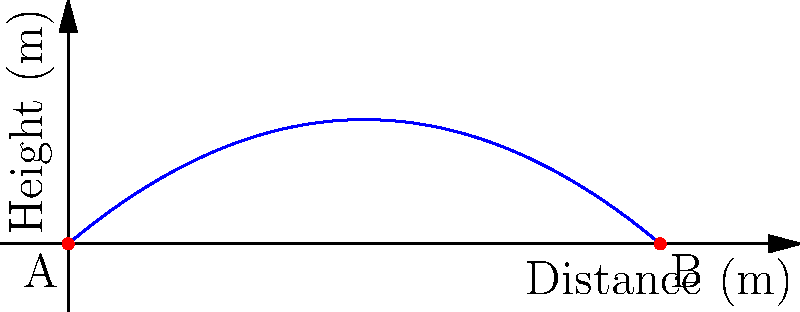As a female footballer promoting women's sports, you're demonstrating a powerful kick to inspire young girls. You kick a football with an initial velocity of 25 m/s at an angle of 40° above the horizontal. Assuming no air resistance, what is the maximum distance the ball will travel before hitting the ground? (Use $g = 9.8$ m/s², and round your answer to the nearest meter.) To solve this problem, we'll use the equations of projectile motion:

1) First, let's break down the initial velocity into its x and y components:
   $v_{0x} = v_0 \cos(\theta) = 25 \cos(40°) = 19.15$ m/s
   $v_{0y} = v_0 \sin(\theta) = 25 \sin(40°) = 16.07$ m/s

2) The time of flight is twice the time it takes for the ball to reach its maximum height. At the highest point, the vertical velocity is zero:
   $0 = v_{0y} - gt$
   $t = \frac{v_{0y}}{g} = \frac{16.07}{9.8} = 1.64$ seconds

3) The total time of flight is twice this:
   $T = 2t = 2(1.64) = 3.28$ seconds

4) The horizontal distance traveled is:
   $d = v_{0x} \cdot T = 19.15 \cdot 3.28 = 62.81$ meters

5) Rounding to the nearest meter:
   $d \approx 63$ meters

This calculation demonstrates the impressive distance a well-executed kick can achieve, highlighting the power and skill in women's football.
Answer: 63 meters 